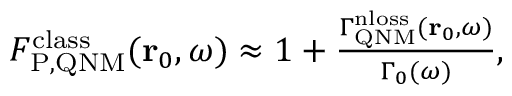<formula> <loc_0><loc_0><loc_500><loc_500>\begin{array} { r } { F _ { P , Q N M } ^ { c l a s s } ( r _ { 0 } , \omega ) \approx 1 + \frac { \Gamma _ { Q N M } ^ { n l o s s } ( r _ { 0 } , \omega ) } { \Gamma _ { 0 } ( \omega ) } , } \end{array}</formula> 